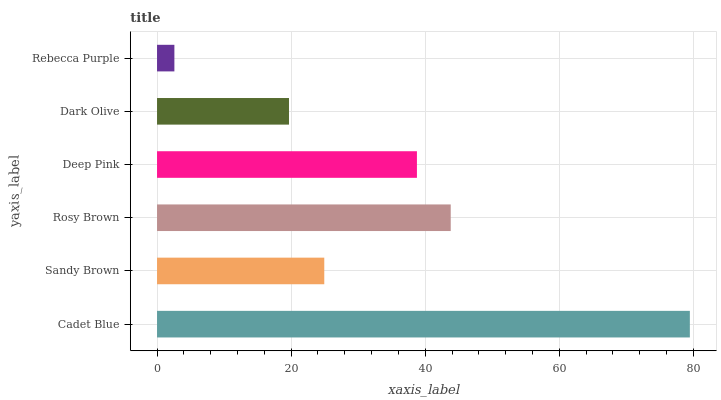Is Rebecca Purple the minimum?
Answer yes or no. Yes. Is Cadet Blue the maximum?
Answer yes or no. Yes. Is Sandy Brown the minimum?
Answer yes or no. No. Is Sandy Brown the maximum?
Answer yes or no. No. Is Cadet Blue greater than Sandy Brown?
Answer yes or no. Yes. Is Sandy Brown less than Cadet Blue?
Answer yes or no. Yes. Is Sandy Brown greater than Cadet Blue?
Answer yes or no. No. Is Cadet Blue less than Sandy Brown?
Answer yes or no. No. Is Deep Pink the high median?
Answer yes or no. Yes. Is Sandy Brown the low median?
Answer yes or no. Yes. Is Cadet Blue the high median?
Answer yes or no. No. Is Deep Pink the low median?
Answer yes or no. No. 